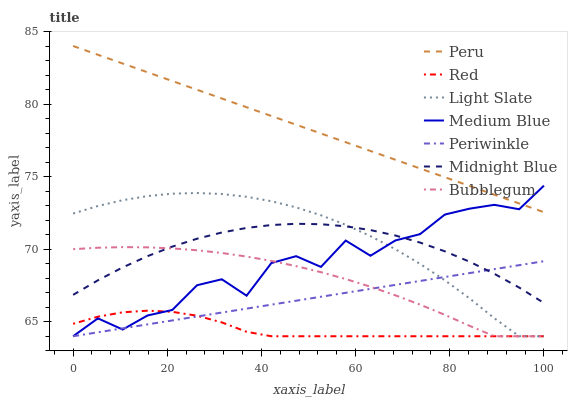Does Light Slate have the minimum area under the curve?
Answer yes or no. No. Does Light Slate have the maximum area under the curve?
Answer yes or no. No. Is Light Slate the smoothest?
Answer yes or no. No. Is Light Slate the roughest?
Answer yes or no. No. Does Peru have the lowest value?
Answer yes or no. No. Does Light Slate have the highest value?
Answer yes or no. No. Is Red less than Peru?
Answer yes or no. Yes. Is Peru greater than Midnight Blue?
Answer yes or no. Yes. Does Red intersect Peru?
Answer yes or no. No. 